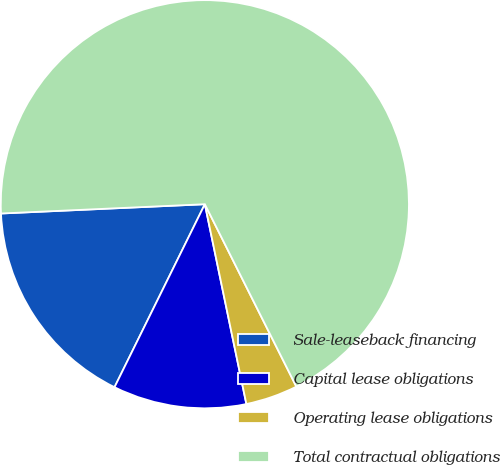Convert chart to OTSL. <chart><loc_0><loc_0><loc_500><loc_500><pie_chart><fcel>Sale-leaseback financing<fcel>Capital lease obligations<fcel>Operating lease obligations<fcel>Total contractual obligations<nl><fcel>16.98%<fcel>10.56%<fcel>4.14%<fcel>68.33%<nl></chart> 